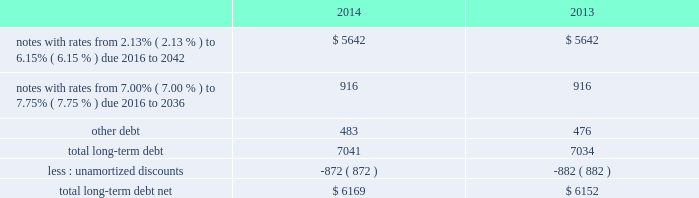As of december 31 , 2014 and 2013 , our liabilities associated with unrecognized tax benefits are not material .
We and our subsidiaries file income tax returns in the u.s .
Federal jurisdiction and various foreign jurisdictions .
With few exceptions , the statute of limitations is no longer open for u.s .
Federal or non-u.s .
Income tax examinations for the years before 2011 , other than with respect to refunds .
U.s .
Income taxes and foreign withholding taxes have not been provided on earnings of $ 291 million , $ 222 million and $ 211 million that have not been distributed by our non-u.s .
Companies as of december 31 , 2014 , 2013 and 2012 .
Our intention is to permanently reinvest these earnings , thereby indefinitely postponing their remittance to the u.s .
If these earnings had been remitted , we estimate that the additional income taxes after foreign tax credits would have been approximately $ 55 million in 2014 , $ 50 million in 2013 and $ 45 million in 2012 .
Our federal and foreign income tax payments , net of refunds received , were $ 1.5 billion in 2014 , $ 787 million in 2013 and $ 890 million in 2012 .
Our 2014 and 2013 net payments reflect a $ 200 million and $ 550 million refund from the irs primarily attributable to our tax-deductible discretionary pension contributions during the fourth quarters of 2013 and 2012 , and our 2012 net payments reflect a $ 153 million refund from the irs related to a 2011 capital loss carryback .
Note 8 2013 debt our long-term debt consisted of the following ( in millions ) : .
In august 2014 , we entered into a new $ 1.5 billion revolving credit facility with a syndicate of banks and concurrently terminated our existing $ 1.5 billion revolving credit facility which was scheduled to expire in august 2016 .
The new credit facility expires august 2019 and we may request and the banks may grant , at their discretion , an increase to the new credit facility of up to an additional $ 500 million .
The credit facility also includes a sublimit of up to $ 300 million available for the issuance of letters of credit .
There were no borrowings outstanding under the new facility through december 31 , 2014 .
Borrowings under the new credit facility would be unsecured and bear interest at rates based , at our option , on a eurodollar rate or a base rate , as defined in the new credit facility .
Each bank 2019s obligation to make loans under the credit facility is subject to , among other things , our compliance with various representations , warranties and covenants , including covenants limiting our ability and certain of our subsidiaries 2019 ability to encumber assets and a covenant not to exceed a maximum leverage ratio , as defined in the credit facility .
The leverage ratio covenant excludes the adjustments recognized in stockholders 2019 equity related to postretirement benefit plans .
As of december 31 , 2014 , we were in compliance with all covenants contained in the credit facility , as well as in our debt agreements .
We have agreements in place with financial institutions to provide for the issuance of commercial paper .
There were no commercial paper borrowings outstanding during 2014 or 2013 .
If we were to issue commercial paper , the borrowings would be supported by the credit facility .
In april 2013 , we repaid $ 150 million of long-term notes with a fixed interest rate of 7.38% ( 7.38 % ) due to their scheduled maturities .
During the next five years , we have scheduled long-term debt maturities of $ 952 million due in 2016 and $ 900 million due in 2019 .
Interest payments were $ 326 million in 2014 , $ 340 million in 2013 and $ 378 million in 2012 .
All of our existing unsecured and unsubordinated indebtedness rank equally in right of payment .
Note 9 2013 postretirement plans defined benefit pension plans and retiree medical and life insurance plans many of our employees are covered by qualified defined benefit pension plans and we provide certain health care and life insurance benefits to eligible retirees ( collectively , postretirement benefit plans ) .
We also sponsor nonqualified defined benefit pension plans to provide for benefits in excess of qualified plan limits .
Non-union represented employees hired after december 2005 do not participate in our qualified defined benefit pension plans , but are eligible to participate in a qualified .
What was the percentage change in total long-term debt net between 2013 and 2014? 
Computations: ((6169 - 6152) / 6152)
Answer: 0.00276. 